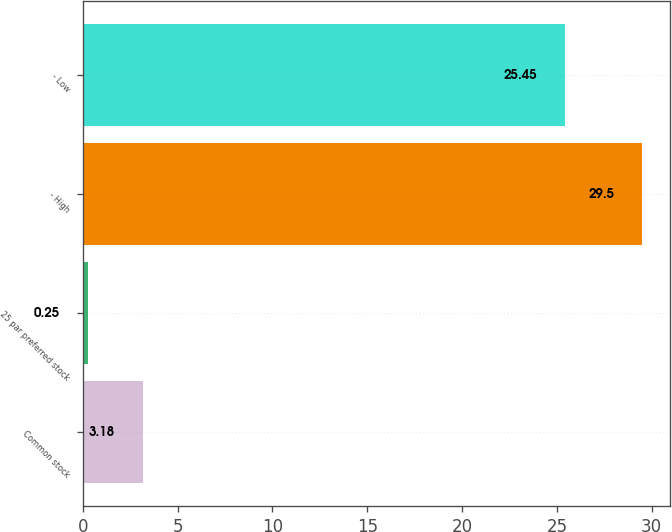<chart> <loc_0><loc_0><loc_500><loc_500><bar_chart><fcel>Common stock<fcel>25 par preferred stock<fcel>- High<fcel>- Low<nl><fcel>3.18<fcel>0.25<fcel>29.5<fcel>25.45<nl></chart> 